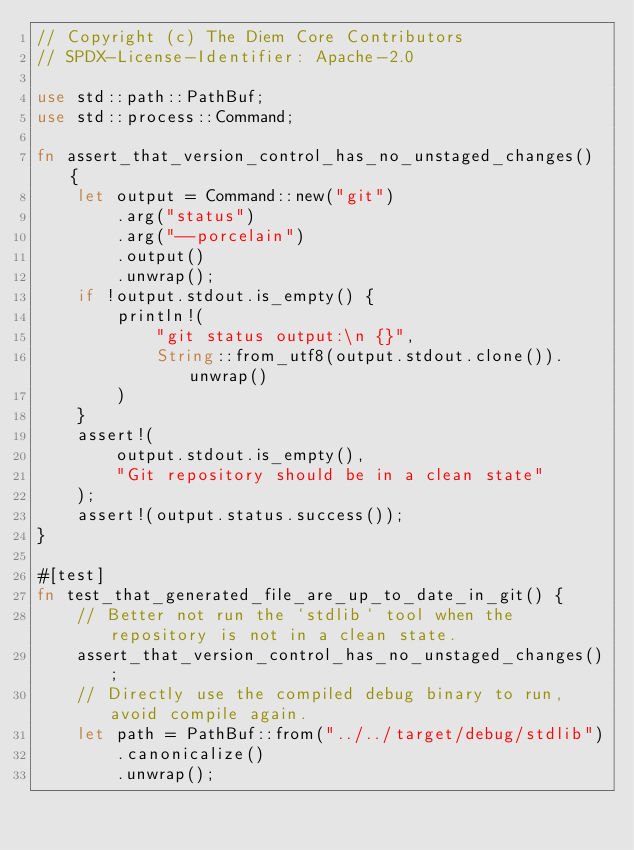Convert code to text. <code><loc_0><loc_0><loc_500><loc_500><_Rust_>// Copyright (c) The Diem Core Contributors
// SPDX-License-Identifier: Apache-2.0

use std::path::PathBuf;
use std::process::Command;

fn assert_that_version_control_has_no_unstaged_changes() {
    let output = Command::new("git")
        .arg("status")
        .arg("--porcelain")
        .output()
        .unwrap();
    if !output.stdout.is_empty() {
        println!(
            "git status output:\n {}",
            String::from_utf8(output.stdout.clone()).unwrap()
        )
    }
    assert!(
        output.stdout.is_empty(),
        "Git repository should be in a clean state"
    );
    assert!(output.status.success());
}

#[test]
fn test_that_generated_file_are_up_to_date_in_git() {
    // Better not run the `stdlib` tool when the repository is not in a clean state.
    assert_that_version_control_has_no_unstaged_changes();
    // Directly use the compiled debug binary to run, avoid compile again.
    let path = PathBuf::from("../../target/debug/stdlib")
        .canonicalize()
        .unwrap();</code> 